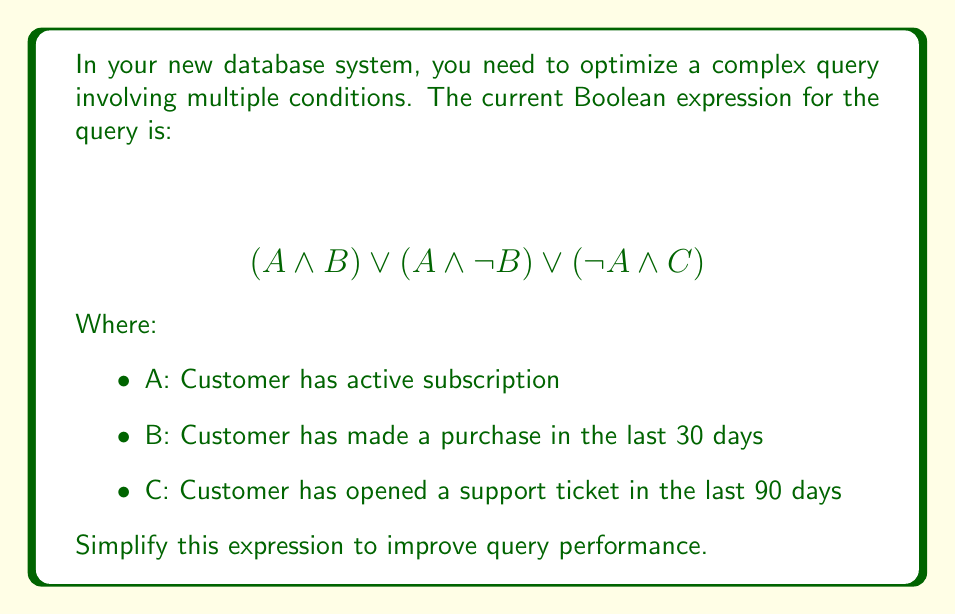Provide a solution to this math problem. Let's simplify this expression step-by-step using Boolean algebra laws:

1) First, let's focus on the first two terms: $(A \land B) \lor (A \land \lnot B)$
   This can be simplified using the distributive law:
   $A \land (B \lor \lnot B)$

2) We know that $(B \lor \lnot B)$ is always true (law of excluded middle), so this simplifies to just $A$

3) Now our expression looks like:
   $A \lor (\lnot A \land C)$

4) We can use the absorption law here:
   $A \lor C$

5) This is our final simplified expression. It means "Customer has active subscription OR Customer has opened a support ticket in the last 90 days"

This simplification reduces the number of conditions the database needs to check, potentially improving query performance.
Answer: $A \lor C$ 